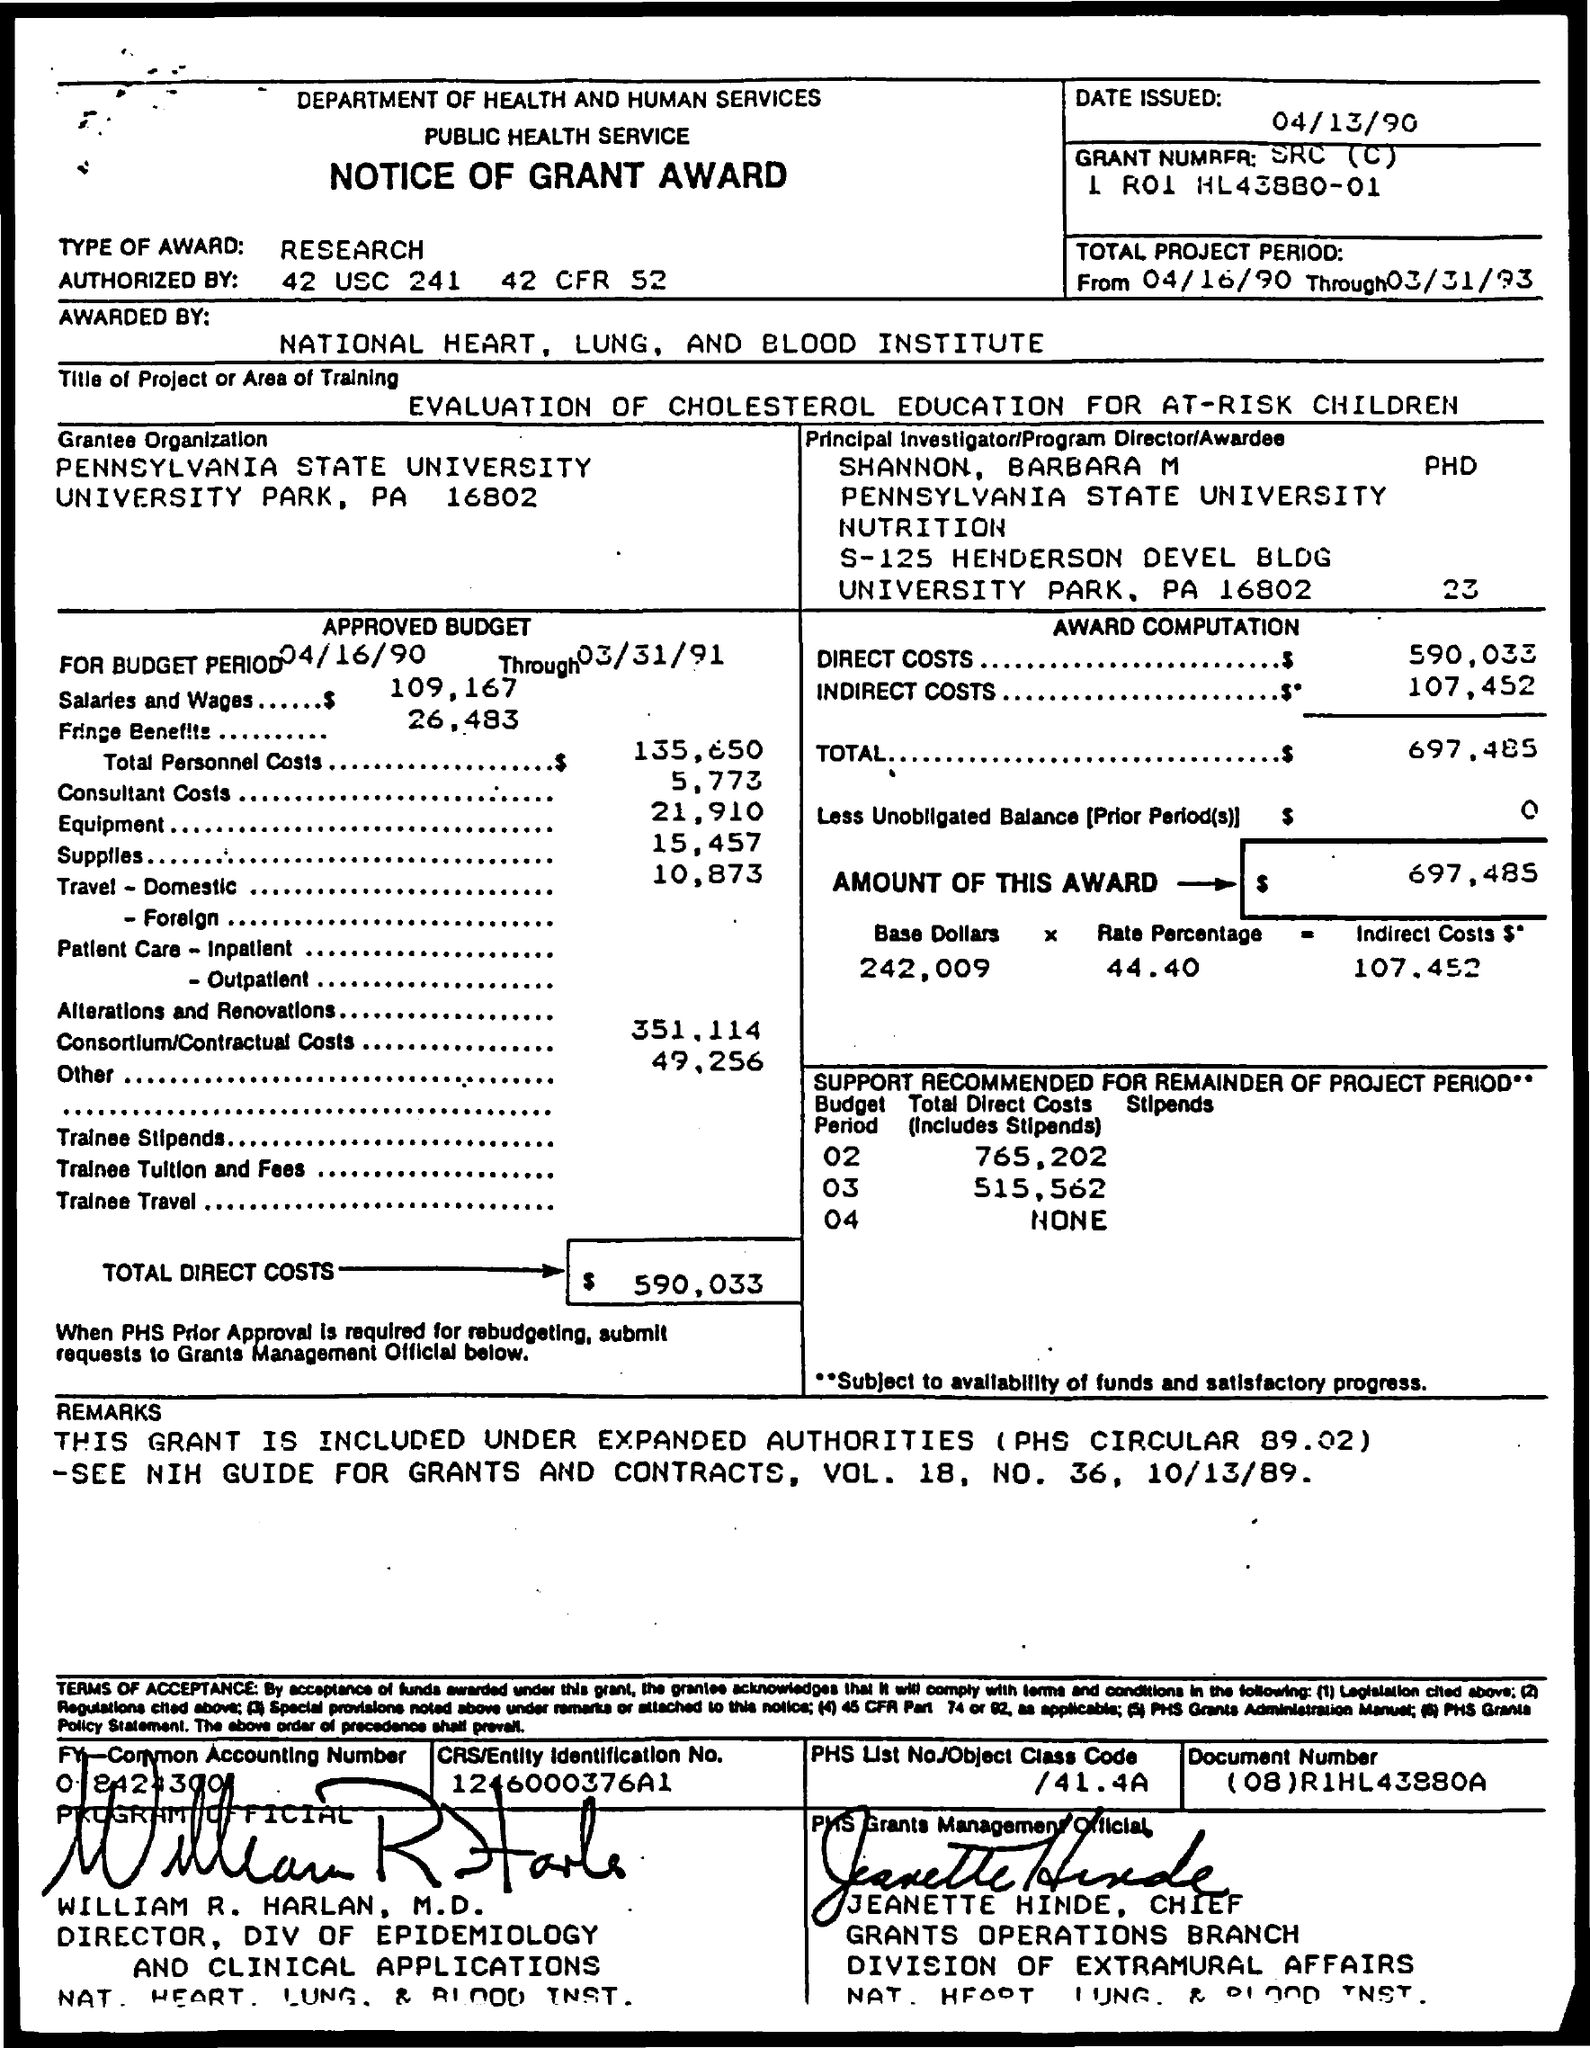What is the Type of Award? The type of award is a research grant given by the National Heart, Lung, and Blood Institute, as identified on the 'Notice of Grant Award' document. It details provisions for a research project aimed at evaluating cholesterol education for at-risk children and is authorized under specific U.S. codes, which suggest the grant is federal and linked to health and public service. 